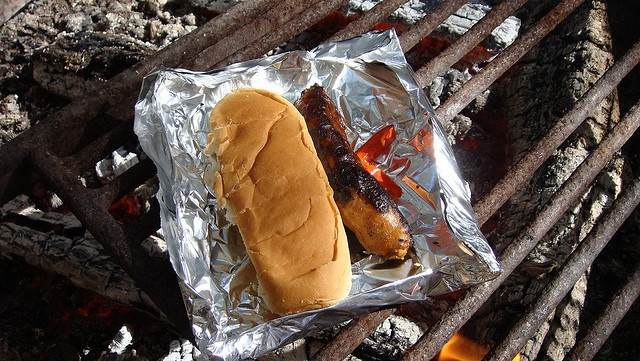Describe the objects in this image and their specific colors. I can see hot dog in gray, red, tan, khaki, and orange tones and hot dog in gray, black, maroon, and brown tones in this image. 